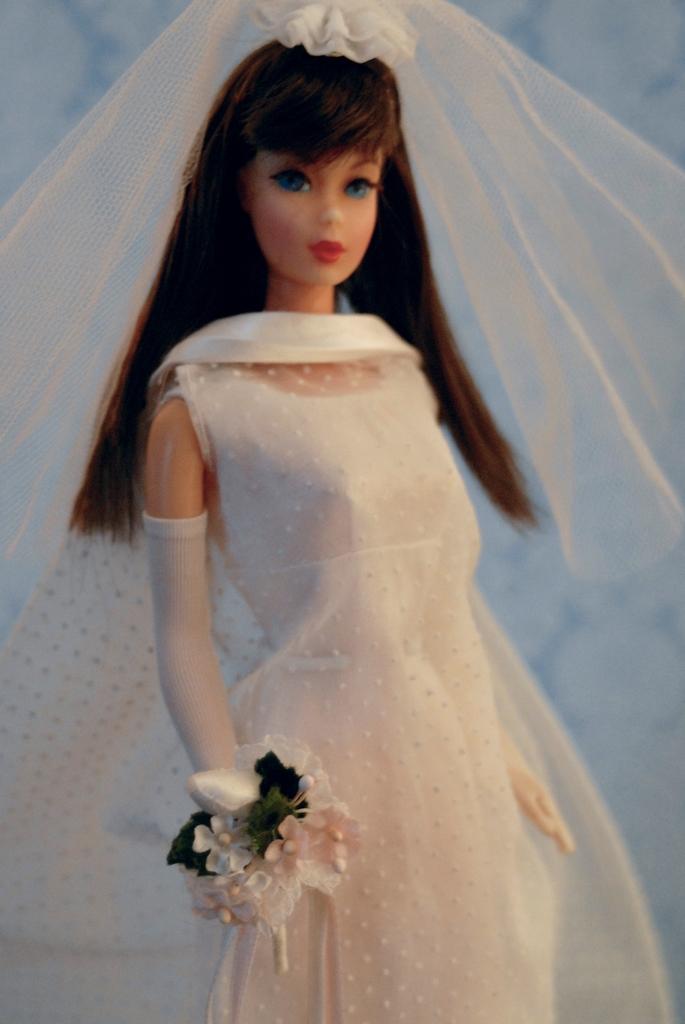Describe this image in one or two sentences. In this picture there is a doll who is wearing white dress and holding plastic flowers. On the back we can see a wall. 